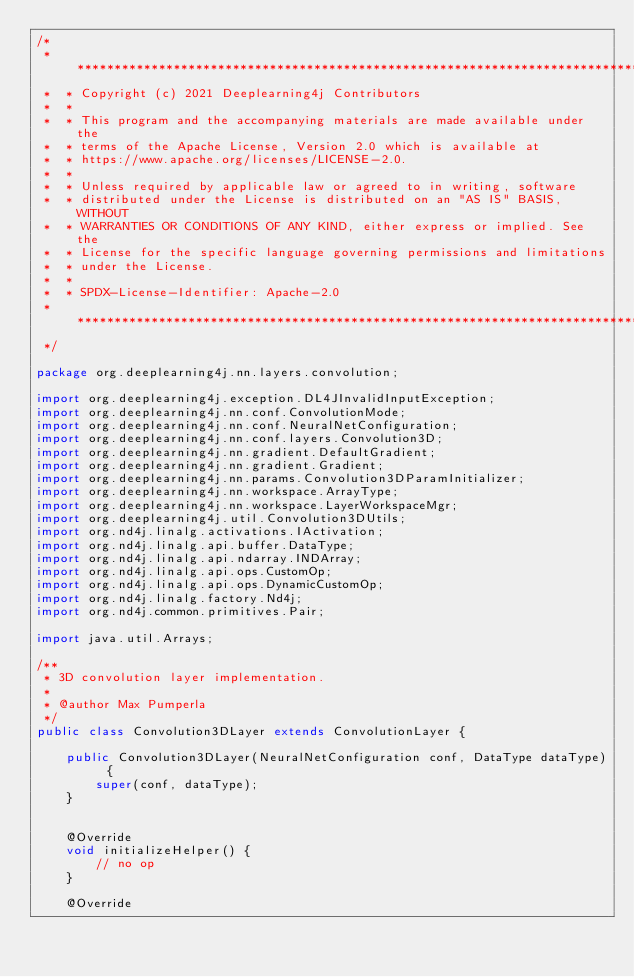<code> <loc_0><loc_0><loc_500><loc_500><_Java_>/*
 *  ******************************************************************************
 *  * Copyright (c) 2021 Deeplearning4j Contributors
 *  *
 *  * This program and the accompanying materials are made available under the
 *  * terms of the Apache License, Version 2.0 which is available at
 *  * https://www.apache.org/licenses/LICENSE-2.0.
 *  *
 *  * Unless required by applicable law or agreed to in writing, software
 *  * distributed under the License is distributed on an "AS IS" BASIS, WITHOUT
 *  * WARRANTIES OR CONDITIONS OF ANY KIND, either express or implied. See the
 *  * License for the specific language governing permissions and limitations
 *  * under the License.
 *  *
 *  * SPDX-License-Identifier: Apache-2.0
 *  *****************************************************************************
 */

package org.deeplearning4j.nn.layers.convolution;

import org.deeplearning4j.exception.DL4JInvalidInputException;
import org.deeplearning4j.nn.conf.ConvolutionMode;
import org.deeplearning4j.nn.conf.NeuralNetConfiguration;
import org.deeplearning4j.nn.conf.layers.Convolution3D;
import org.deeplearning4j.nn.gradient.DefaultGradient;
import org.deeplearning4j.nn.gradient.Gradient;
import org.deeplearning4j.nn.params.Convolution3DParamInitializer;
import org.deeplearning4j.nn.workspace.ArrayType;
import org.deeplearning4j.nn.workspace.LayerWorkspaceMgr;
import org.deeplearning4j.util.Convolution3DUtils;
import org.nd4j.linalg.activations.IActivation;
import org.nd4j.linalg.api.buffer.DataType;
import org.nd4j.linalg.api.ndarray.INDArray;
import org.nd4j.linalg.api.ops.CustomOp;
import org.nd4j.linalg.api.ops.DynamicCustomOp;
import org.nd4j.linalg.factory.Nd4j;
import org.nd4j.common.primitives.Pair;

import java.util.Arrays;

/**
 * 3D convolution layer implementation.
 *
 * @author Max Pumperla
 */
public class Convolution3DLayer extends ConvolutionLayer {

    public Convolution3DLayer(NeuralNetConfiguration conf, DataType dataType) {
        super(conf, dataType);
    }


    @Override
    void initializeHelper() {
        // no op
    }

    @Override</code> 